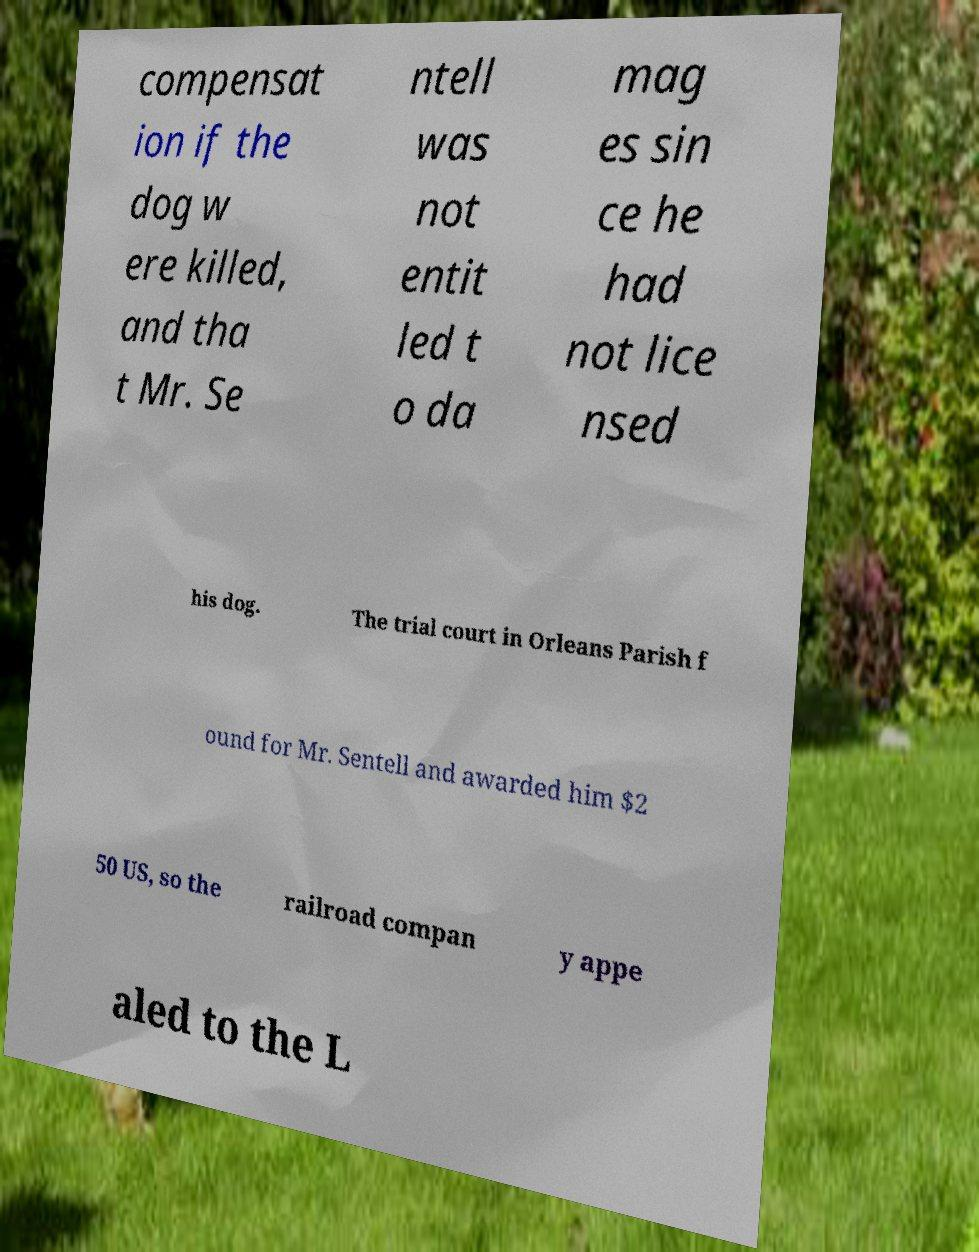For documentation purposes, I need the text within this image transcribed. Could you provide that? compensat ion if the dog w ere killed, and tha t Mr. Se ntell was not entit led t o da mag es sin ce he had not lice nsed his dog. The trial court in Orleans Parish f ound for Mr. Sentell and awarded him $2 50 US, so the railroad compan y appe aled to the L 